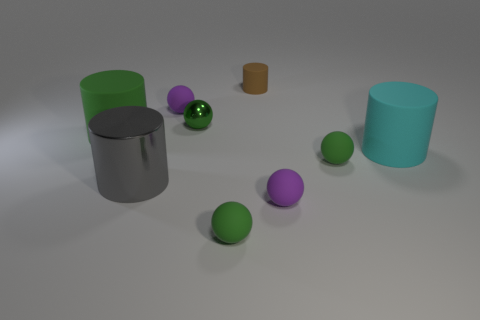How many objects are there in total, and can you describe their colors and shapes? In total, there are nine objects in the image. There are two cylindrical objects on the right, one green and one teal, as well as a smaller brown cylindrical object. Additionally, there are six spherical objects: three are green and two are purple, with one larger purple sphere that stands out due to its size. The remaining spherical object is a smaller shiny green. 